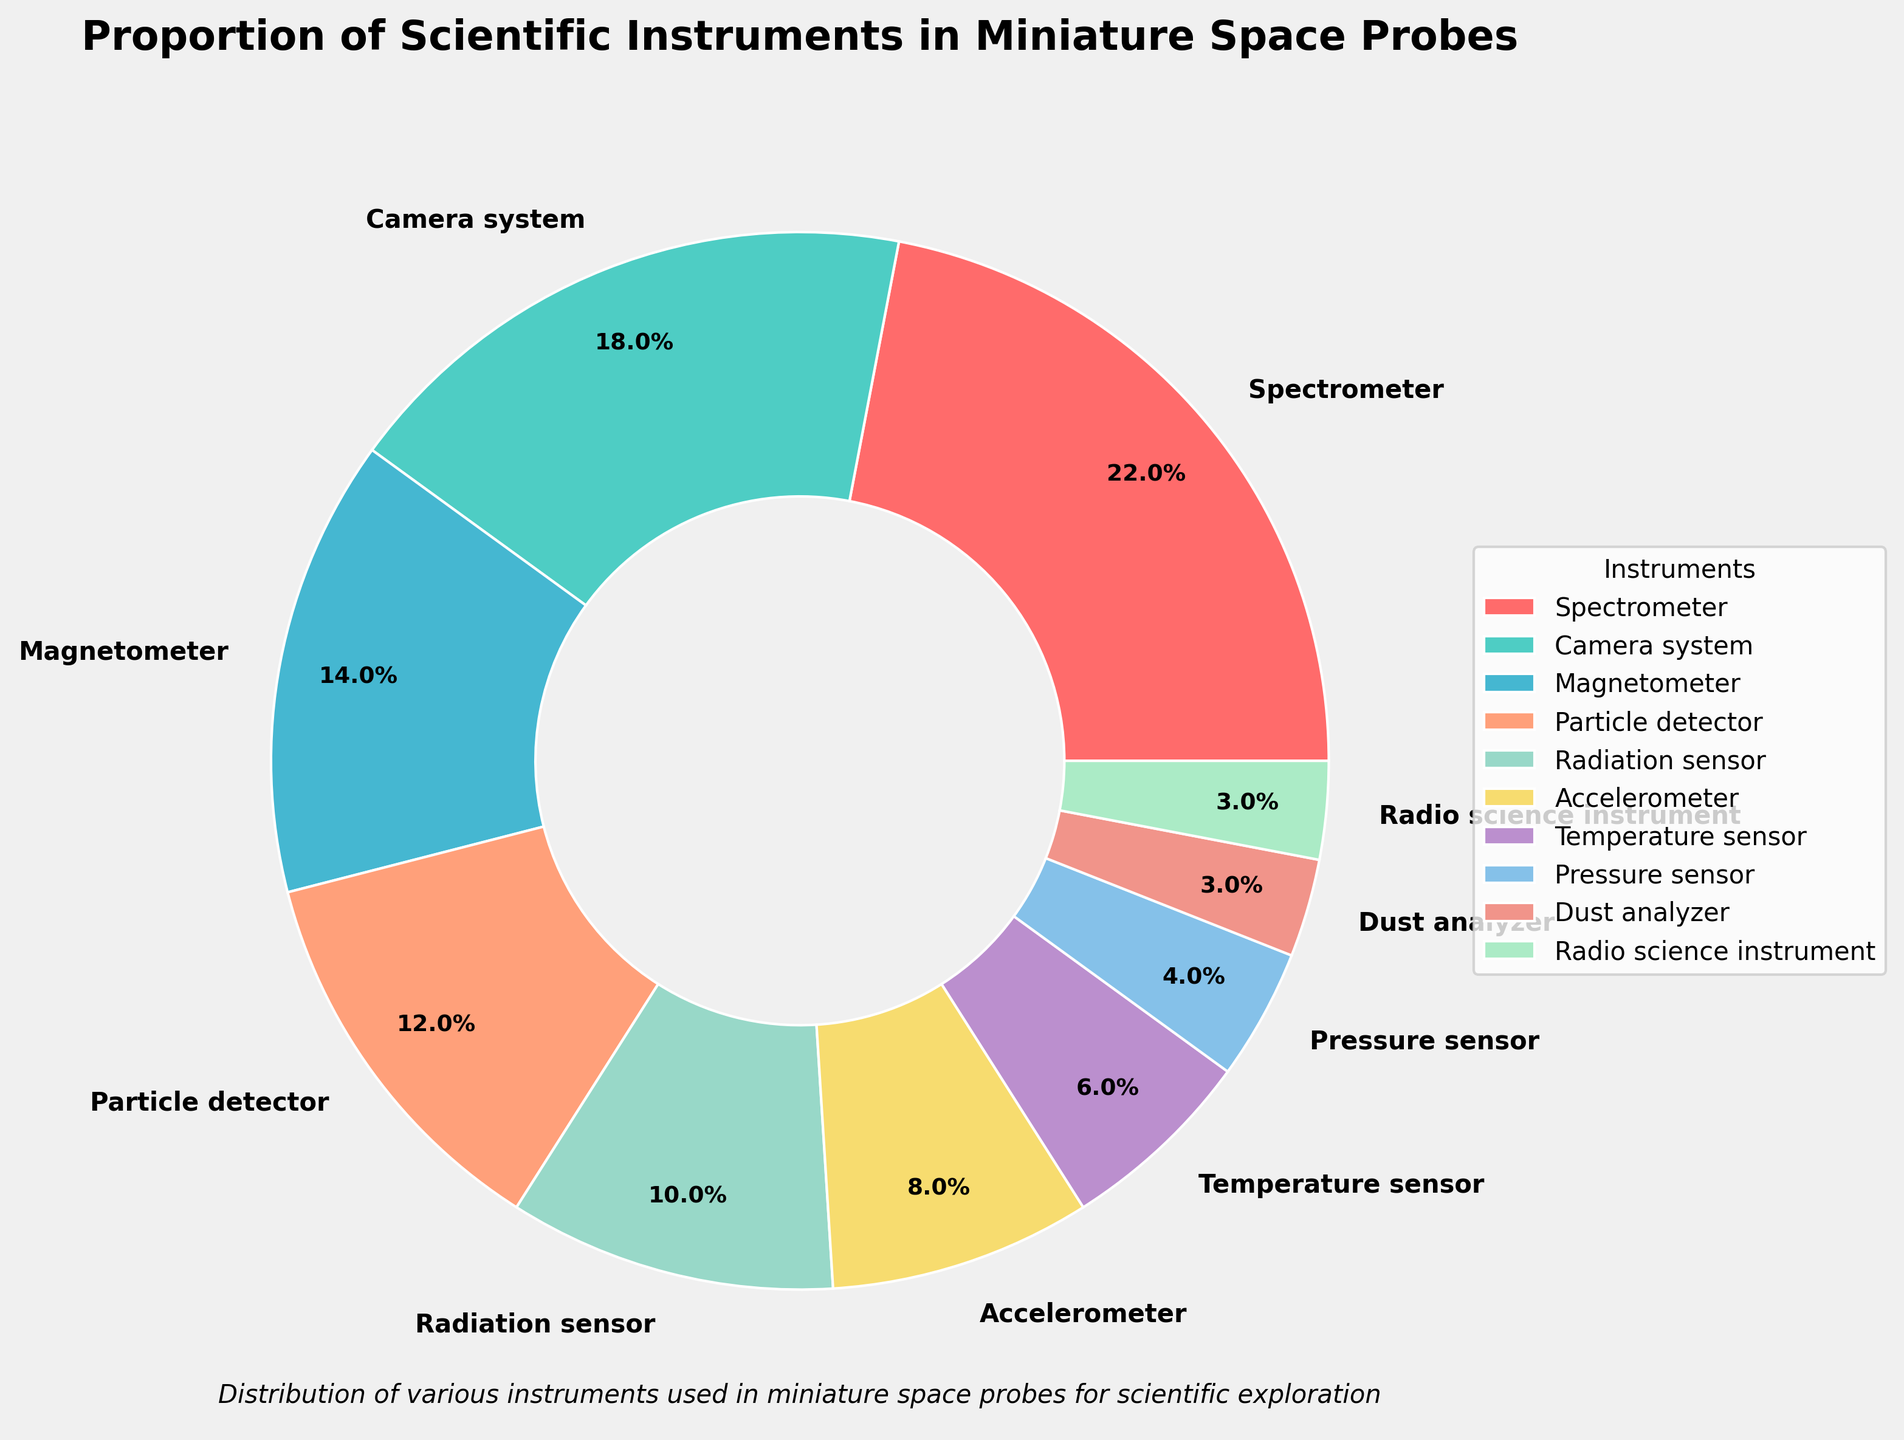Which instrument has the largest proportion? The figure segments show that the Spectrometer segment is the largest. Thus, the Spectrometer has the highest proportion.
Answer: Spectrometer Which instrument has the smallest proportion? The figure segments show that the Dust Analyzer and Radio Science Instrument segments are the smallest. Thus, they share the smallest proportion.
Answer: Dust Analyzer and Radio Science Instrument How many percentage points greater is the Spectrometer's proportion compared to the Pressure Sensor's proportion? The Spectrometer's proportion is 22%, and the Pressure Sensor's proportion is 4%. Subtracting these gives: 22% - 4% = 18%.
Answer: 18 percentage points What is the combined proportion of the Camera System, Particle Detector, and Radiation Sensor? The Camera System is 18%, Particle Detector is 12%, and Radiation Sensor is 10%. Summing these: 18% + 12% + 10% = 40%.
Answer: 40% Which instruments together account for more than 25% of the total? Summing the different instruments: Spectrometer (22%) + Camera System (18%) = 40%, which is more than 25%. No other smaller group exceeds 25%, so only the Spectrometer and Camera System together account for such a large proportion.
Answer: Spectrometer and Camera System Which instruments have a proportion less than 10%? Observing the pie chart, instruments with less than 10% are Accelerometer (8%), Temperature Sensor (6%), Pressure Sensor (4%), Dust Analyzer (3%), and Radio Science Instrument (3%).
Answer: Accelerometer, Temperature Sensor, Pressure Sensor, Dust Analyzer, and Radio Science Instrument What is the median percentage of all listed instruments? Listing the percentages in ascending order: 3, 3, 4, 6, 8, 10, 12, 14, 18, 22. The middle values are 8 and 10. The median is the average of these two: (8% + 10%)/2 = 9%.
Answer: 9% Which instrument's proportion is double the proportion of the Pressure Sensor? The Pressure Sensor proportion is 4%. The Magnetometer proportion is 14%, which is not double, but the Accelerometer proportion is 8%, which matches double of 4%.
Answer: Accelerometer How much more is the combined proportion of the three largest instruments compared to the three smallest instruments? The three largest instruments: Spectrometer (22%), Camera System (18%), Magnetometer (14%). Their sum is 22% + 18% + 14% = 54%. The three smallest: Dust Analyzer (3%), Radio Science Instrument (3%), Pressure Sensor (4%). Their sum is 3% + 3% + 4% = 10%. Difference is 54% - 10% = 44%.
Answer: 44% 